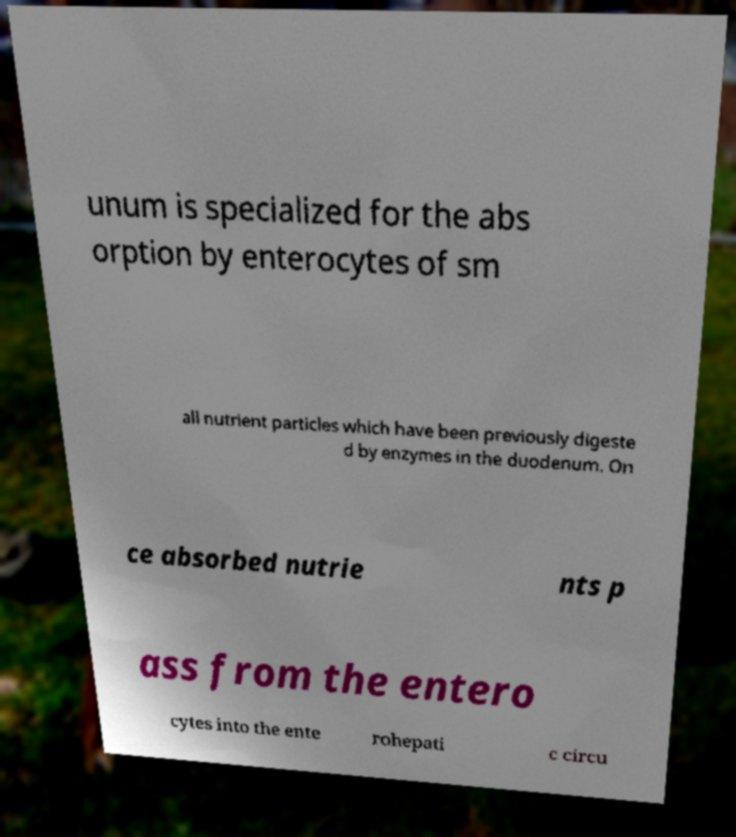Can you read and provide the text displayed in the image?This photo seems to have some interesting text. Can you extract and type it out for me? unum is specialized for the abs orption by enterocytes of sm all nutrient particles which have been previously digeste d by enzymes in the duodenum. On ce absorbed nutrie nts p ass from the entero cytes into the ente rohepati c circu 